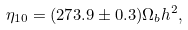Convert formula to latex. <formula><loc_0><loc_0><loc_500><loc_500>\eta _ { 1 0 } = ( 2 7 3 . 9 \pm 0 . 3 ) { \Omega _ { b } h ^ { 2 } } ,</formula> 